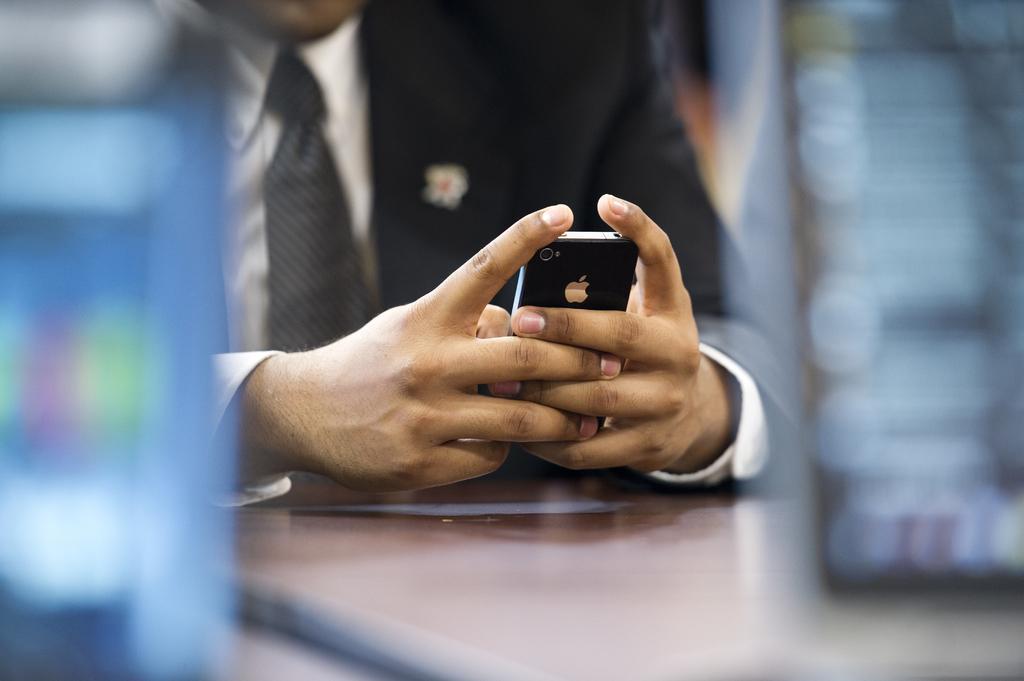Please provide a concise description of this image. In this image there is one person who is sitting and he is holding a phone and he is wearing black suit and white shirt and tie in front of him there is one table. 